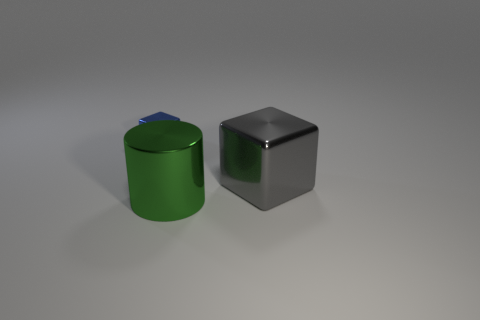Is there any other thing that is the same shape as the green object?
Offer a very short reply. No. Are any things visible?
Provide a succinct answer. Yes. There is a shiny block to the left of the block on the right side of the metal thing to the left of the large green metal cylinder; what size is it?
Give a very brief answer. Small. Is the shape of the tiny metallic object the same as the thing right of the green metal thing?
Offer a terse response. Yes. Are there any small blocks that have the same color as the small thing?
Your answer should be compact. No. What number of blocks are big green metallic things or large gray things?
Provide a succinct answer. 1. Is there another small cyan matte object of the same shape as the small object?
Give a very brief answer. No. Are there fewer metallic cylinders behind the tiny blue block than big gray spheres?
Offer a very short reply. No. How many large green objects are there?
Your answer should be very brief. 1. What number of large things are the same material as the green cylinder?
Offer a very short reply. 1. 